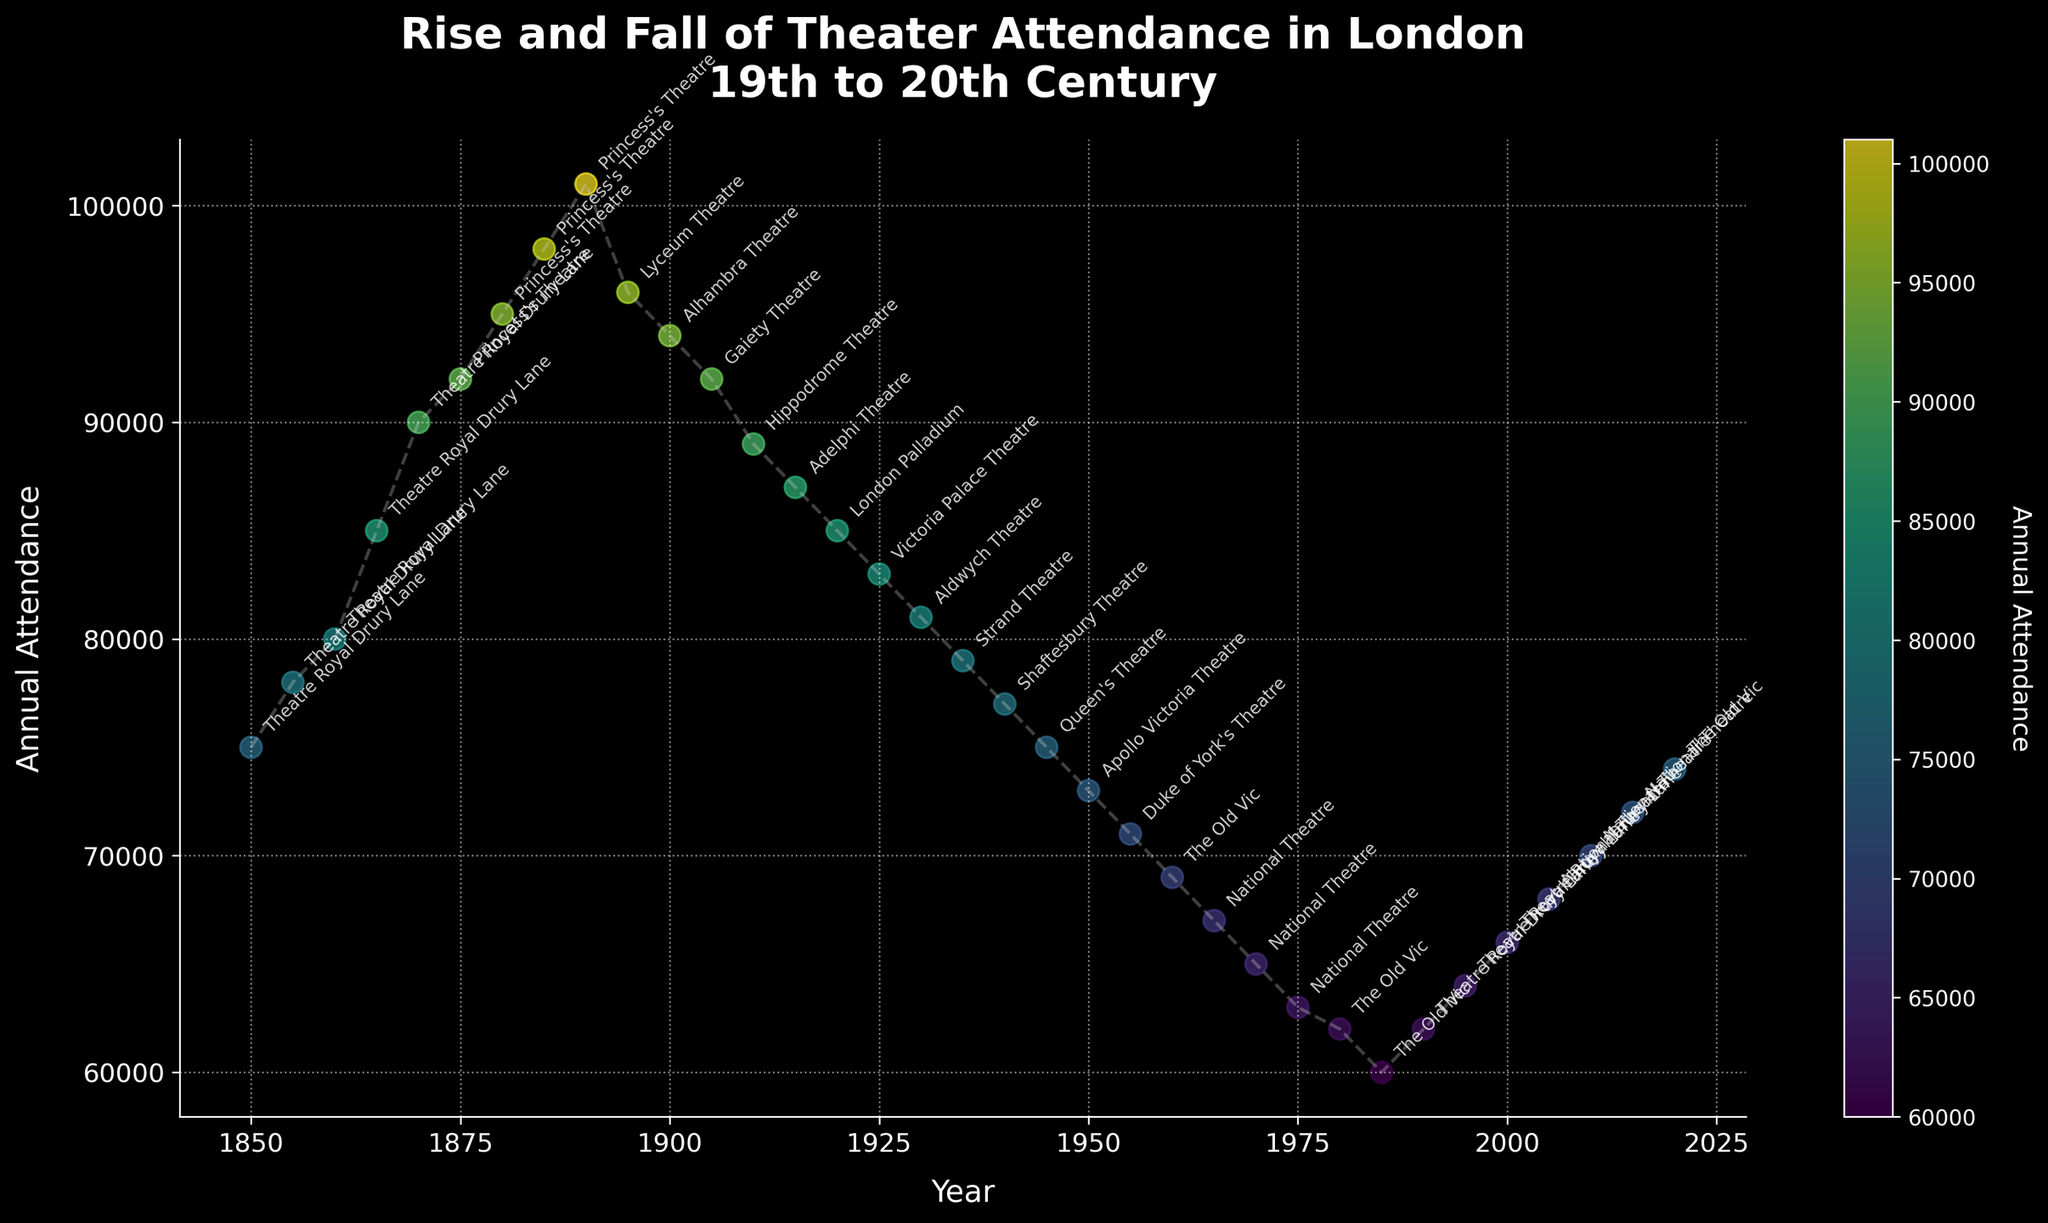what is the title of the figure? The title of the figure is displayed prominently at the top and is in larger font size and bolded to attract the viewer’s attention. It reads "Rise and Fall of Theater Attendance in London\n19th to 20th Century".
Answer: Rise and Fall of Theater Attendance in London\n19th to 20th Century How many theaters are listed in the figure? By counting the number of unique theater names annotated next to the data points in the plot, we can determine the total number of theaters listed.
Answer: 19 Which theater had the highest attendance and in which year? By looking at the y-axis for the highest data point and locating the corresponding annotation, we can identify that the Princess's Theatre had the highest attendance in 1890.
Answer: Princess's Theatre in 1890 What is the total attendance for all theaters in the year 1925? To find this, note the attendance value for 1925 (Victoria Palace Theatre) directly from the plot and use it since only one theater is listed. So, Annual Attendance is 83000.
Answer: 83000 What's the trend in theater attendance from 1850 to 1950? Observing the overall pattern of the data points from 1850 to 1950, the attendance increases from 1850 to 1890 and then shows a general decline after that up to 1950.
Answer: First increases, then declines What is the average annual attendance between 2010 and 2020? To calculate the average, add the attendance values for 2010 (70000), 2015 (72000), and 2020 (74000), then divide by the number of data points (3). (70000 + 72000 + 74000) / 3 = 72000
Answer: 72000 Which two theaters had equal attendance, and what was the value? By examining the data points and annotations, we find that the Theatre Royal Drury Lane in 1990 and The Old Vic in 1980 both had an attendance of 62000.
Answer: Theatre Royal Drury Lane in 1990 and The Old Vic in 1980 at 62000 In which decade did the National Theatre see a decrease in attendance? Identify the change in attendance by comparing the National Theatre's values at each decade: 1960s (67000) to 1970s (65000) indicates a decrease.
Answer: 1970s 